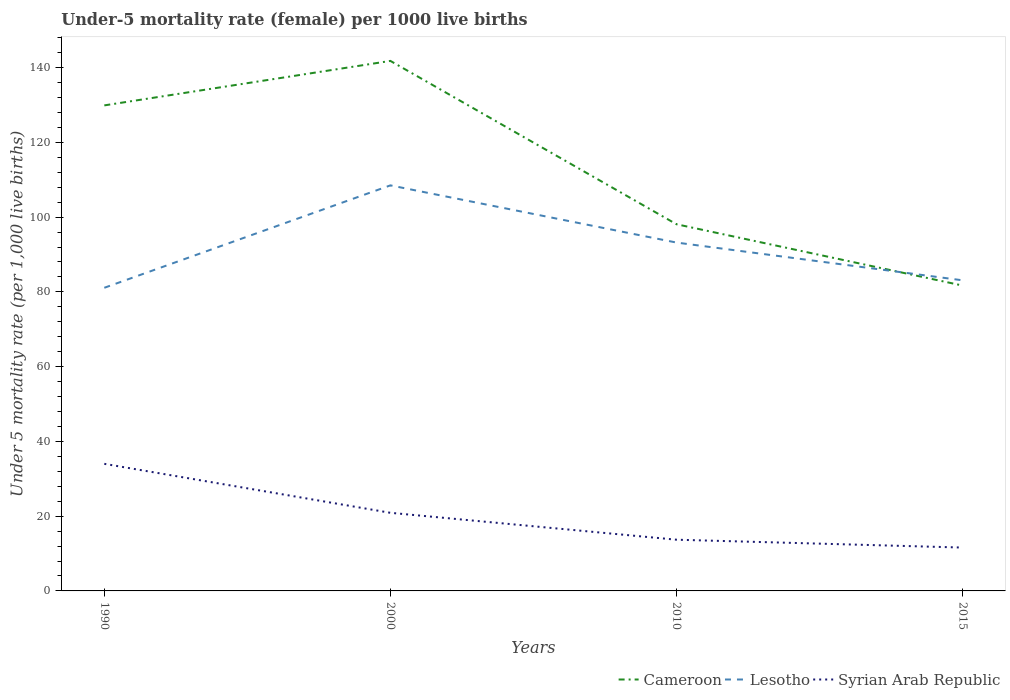Does the line corresponding to Syrian Arab Republic intersect with the line corresponding to Cameroon?
Ensure brevity in your answer.  No. Is the number of lines equal to the number of legend labels?
Ensure brevity in your answer.  Yes. Across all years, what is the maximum under-five mortality rate in Lesotho?
Give a very brief answer. 81.1. In which year was the under-five mortality rate in Cameroon maximum?
Keep it short and to the point. 2015. What is the total under-five mortality rate in Syrian Arab Republic in the graph?
Your answer should be compact. 13.1. What is the difference between the highest and the second highest under-five mortality rate in Syrian Arab Republic?
Ensure brevity in your answer.  22.4. How many years are there in the graph?
Your answer should be compact. 4. What is the difference between two consecutive major ticks on the Y-axis?
Provide a succinct answer. 20. Does the graph contain any zero values?
Provide a short and direct response. No. Does the graph contain grids?
Keep it short and to the point. No. Where does the legend appear in the graph?
Offer a very short reply. Bottom right. What is the title of the graph?
Offer a very short reply. Under-5 mortality rate (female) per 1000 live births. Does "Netherlands" appear as one of the legend labels in the graph?
Provide a succinct answer. No. What is the label or title of the Y-axis?
Make the answer very short. Under 5 mortality rate (per 1,0 live births). What is the Under 5 mortality rate (per 1,000 live births) of Cameroon in 1990?
Your answer should be compact. 129.9. What is the Under 5 mortality rate (per 1,000 live births) of Lesotho in 1990?
Provide a short and direct response. 81.1. What is the Under 5 mortality rate (per 1,000 live births) in Syrian Arab Republic in 1990?
Your answer should be compact. 34. What is the Under 5 mortality rate (per 1,000 live births) in Cameroon in 2000?
Provide a succinct answer. 141.8. What is the Under 5 mortality rate (per 1,000 live births) in Lesotho in 2000?
Offer a terse response. 108.5. What is the Under 5 mortality rate (per 1,000 live births) in Syrian Arab Republic in 2000?
Provide a short and direct response. 20.9. What is the Under 5 mortality rate (per 1,000 live births) in Cameroon in 2010?
Make the answer very short. 98.1. What is the Under 5 mortality rate (per 1,000 live births) of Lesotho in 2010?
Your answer should be compact. 93.2. What is the Under 5 mortality rate (per 1,000 live births) in Cameroon in 2015?
Your response must be concise. 81.7. What is the Under 5 mortality rate (per 1,000 live births) in Lesotho in 2015?
Your response must be concise. 83.1. Across all years, what is the maximum Under 5 mortality rate (per 1,000 live births) of Cameroon?
Ensure brevity in your answer.  141.8. Across all years, what is the maximum Under 5 mortality rate (per 1,000 live births) in Lesotho?
Your response must be concise. 108.5. Across all years, what is the minimum Under 5 mortality rate (per 1,000 live births) in Cameroon?
Provide a succinct answer. 81.7. Across all years, what is the minimum Under 5 mortality rate (per 1,000 live births) of Lesotho?
Make the answer very short. 81.1. Across all years, what is the minimum Under 5 mortality rate (per 1,000 live births) in Syrian Arab Republic?
Your response must be concise. 11.6. What is the total Under 5 mortality rate (per 1,000 live births) in Cameroon in the graph?
Ensure brevity in your answer.  451.5. What is the total Under 5 mortality rate (per 1,000 live births) of Lesotho in the graph?
Your response must be concise. 365.9. What is the total Under 5 mortality rate (per 1,000 live births) in Syrian Arab Republic in the graph?
Your answer should be very brief. 80.2. What is the difference between the Under 5 mortality rate (per 1,000 live births) in Cameroon in 1990 and that in 2000?
Provide a short and direct response. -11.9. What is the difference between the Under 5 mortality rate (per 1,000 live births) in Lesotho in 1990 and that in 2000?
Your answer should be very brief. -27.4. What is the difference between the Under 5 mortality rate (per 1,000 live births) of Syrian Arab Republic in 1990 and that in 2000?
Make the answer very short. 13.1. What is the difference between the Under 5 mortality rate (per 1,000 live births) of Cameroon in 1990 and that in 2010?
Your answer should be compact. 31.8. What is the difference between the Under 5 mortality rate (per 1,000 live births) in Lesotho in 1990 and that in 2010?
Give a very brief answer. -12.1. What is the difference between the Under 5 mortality rate (per 1,000 live births) of Syrian Arab Republic in 1990 and that in 2010?
Keep it short and to the point. 20.3. What is the difference between the Under 5 mortality rate (per 1,000 live births) in Cameroon in 1990 and that in 2015?
Provide a succinct answer. 48.2. What is the difference between the Under 5 mortality rate (per 1,000 live births) of Lesotho in 1990 and that in 2015?
Your response must be concise. -2. What is the difference between the Under 5 mortality rate (per 1,000 live births) of Syrian Arab Republic in 1990 and that in 2015?
Provide a succinct answer. 22.4. What is the difference between the Under 5 mortality rate (per 1,000 live births) of Cameroon in 2000 and that in 2010?
Provide a succinct answer. 43.7. What is the difference between the Under 5 mortality rate (per 1,000 live births) in Lesotho in 2000 and that in 2010?
Your answer should be very brief. 15.3. What is the difference between the Under 5 mortality rate (per 1,000 live births) of Syrian Arab Republic in 2000 and that in 2010?
Provide a succinct answer. 7.2. What is the difference between the Under 5 mortality rate (per 1,000 live births) in Cameroon in 2000 and that in 2015?
Ensure brevity in your answer.  60.1. What is the difference between the Under 5 mortality rate (per 1,000 live births) in Lesotho in 2000 and that in 2015?
Your answer should be very brief. 25.4. What is the difference between the Under 5 mortality rate (per 1,000 live births) in Syrian Arab Republic in 2000 and that in 2015?
Offer a very short reply. 9.3. What is the difference between the Under 5 mortality rate (per 1,000 live births) of Lesotho in 2010 and that in 2015?
Ensure brevity in your answer.  10.1. What is the difference between the Under 5 mortality rate (per 1,000 live births) of Cameroon in 1990 and the Under 5 mortality rate (per 1,000 live births) of Lesotho in 2000?
Ensure brevity in your answer.  21.4. What is the difference between the Under 5 mortality rate (per 1,000 live births) in Cameroon in 1990 and the Under 5 mortality rate (per 1,000 live births) in Syrian Arab Republic in 2000?
Offer a very short reply. 109. What is the difference between the Under 5 mortality rate (per 1,000 live births) of Lesotho in 1990 and the Under 5 mortality rate (per 1,000 live births) of Syrian Arab Republic in 2000?
Provide a succinct answer. 60.2. What is the difference between the Under 5 mortality rate (per 1,000 live births) in Cameroon in 1990 and the Under 5 mortality rate (per 1,000 live births) in Lesotho in 2010?
Give a very brief answer. 36.7. What is the difference between the Under 5 mortality rate (per 1,000 live births) of Cameroon in 1990 and the Under 5 mortality rate (per 1,000 live births) of Syrian Arab Republic in 2010?
Make the answer very short. 116.2. What is the difference between the Under 5 mortality rate (per 1,000 live births) of Lesotho in 1990 and the Under 5 mortality rate (per 1,000 live births) of Syrian Arab Republic in 2010?
Provide a succinct answer. 67.4. What is the difference between the Under 5 mortality rate (per 1,000 live births) in Cameroon in 1990 and the Under 5 mortality rate (per 1,000 live births) in Lesotho in 2015?
Your answer should be very brief. 46.8. What is the difference between the Under 5 mortality rate (per 1,000 live births) of Cameroon in 1990 and the Under 5 mortality rate (per 1,000 live births) of Syrian Arab Republic in 2015?
Provide a short and direct response. 118.3. What is the difference between the Under 5 mortality rate (per 1,000 live births) in Lesotho in 1990 and the Under 5 mortality rate (per 1,000 live births) in Syrian Arab Republic in 2015?
Make the answer very short. 69.5. What is the difference between the Under 5 mortality rate (per 1,000 live births) in Cameroon in 2000 and the Under 5 mortality rate (per 1,000 live births) in Lesotho in 2010?
Offer a terse response. 48.6. What is the difference between the Under 5 mortality rate (per 1,000 live births) of Cameroon in 2000 and the Under 5 mortality rate (per 1,000 live births) of Syrian Arab Republic in 2010?
Offer a terse response. 128.1. What is the difference between the Under 5 mortality rate (per 1,000 live births) of Lesotho in 2000 and the Under 5 mortality rate (per 1,000 live births) of Syrian Arab Republic in 2010?
Provide a succinct answer. 94.8. What is the difference between the Under 5 mortality rate (per 1,000 live births) in Cameroon in 2000 and the Under 5 mortality rate (per 1,000 live births) in Lesotho in 2015?
Your answer should be compact. 58.7. What is the difference between the Under 5 mortality rate (per 1,000 live births) of Cameroon in 2000 and the Under 5 mortality rate (per 1,000 live births) of Syrian Arab Republic in 2015?
Your answer should be compact. 130.2. What is the difference between the Under 5 mortality rate (per 1,000 live births) in Lesotho in 2000 and the Under 5 mortality rate (per 1,000 live births) in Syrian Arab Republic in 2015?
Provide a succinct answer. 96.9. What is the difference between the Under 5 mortality rate (per 1,000 live births) in Cameroon in 2010 and the Under 5 mortality rate (per 1,000 live births) in Lesotho in 2015?
Provide a short and direct response. 15. What is the difference between the Under 5 mortality rate (per 1,000 live births) in Cameroon in 2010 and the Under 5 mortality rate (per 1,000 live births) in Syrian Arab Republic in 2015?
Offer a terse response. 86.5. What is the difference between the Under 5 mortality rate (per 1,000 live births) in Lesotho in 2010 and the Under 5 mortality rate (per 1,000 live births) in Syrian Arab Republic in 2015?
Provide a succinct answer. 81.6. What is the average Under 5 mortality rate (per 1,000 live births) of Cameroon per year?
Make the answer very short. 112.88. What is the average Under 5 mortality rate (per 1,000 live births) of Lesotho per year?
Offer a terse response. 91.47. What is the average Under 5 mortality rate (per 1,000 live births) of Syrian Arab Republic per year?
Make the answer very short. 20.05. In the year 1990, what is the difference between the Under 5 mortality rate (per 1,000 live births) of Cameroon and Under 5 mortality rate (per 1,000 live births) of Lesotho?
Provide a succinct answer. 48.8. In the year 1990, what is the difference between the Under 5 mortality rate (per 1,000 live births) of Cameroon and Under 5 mortality rate (per 1,000 live births) of Syrian Arab Republic?
Your answer should be very brief. 95.9. In the year 1990, what is the difference between the Under 5 mortality rate (per 1,000 live births) of Lesotho and Under 5 mortality rate (per 1,000 live births) of Syrian Arab Republic?
Your answer should be very brief. 47.1. In the year 2000, what is the difference between the Under 5 mortality rate (per 1,000 live births) in Cameroon and Under 5 mortality rate (per 1,000 live births) in Lesotho?
Make the answer very short. 33.3. In the year 2000, what is the difference between the Under 5 mortality rate (per 1,000 live births) of Cameroon and Under 5 mortality rate (per 1,000 live births) of Syrian Arab Republic?
Ensure brevity in your answer.  120.9. In the year 2000, what is the difference between the Under 5 mortality rate (per 1,000 live births) of Lesotho and Under 5 mortality rate (per 1,000 live births) of Syrian Arab Republic?
Offer a terse response. 87.6. In the year 2010, what is the difference between the Under 5 mortality rate (per 1,000 live births) in Cameroon and Under 5 mortality rate (per 1,000 live births) in Lesotho?
Give a very brief answer. 4.9. In the year 2010, what is the difference between the Under 5 mortality rate (per 1,000 live births) in Cameroon and Under 5 mortality rate (per 1,000 live births) in Syrian Arab Republic?
Keep it short and to the point. 84.4. In the year 2010, what is the difference between the Under 5 mortality rate (per 1,000 live births) in Lesotho and Under 5 mortality rate (per 1,000 live births) in Syrian Arab Republic?
Provide a succinct answer. 79.5. In the year 2015, what is the difference between the Under 5 mortality rate (per 1,000 live births) of Cameroon and Under 5 mortality rate (per 1,000 live births) of Syrian Arab Republic?
Offer a terse response. 70.1. In the year 2015, what is the difference between the Under 5 mortality rate (per 1,000 live births) in Lesotho and Under 5 mortality rate (per 1,000 live births) in Syrian Arab Republic?
Your answer should be compact. 71.5. What is the ratio of the Under 5 mortality rate (per 1,000 live births) of Cameroon in 1990 to that in 2000?
Offer a terse response. 0.92. What is the ratio of the Under 5 mortality rate (per 1,000 live births) in Lesotho in 1990 to that in 2000?
Keep it short and to the point. 0.75. What is the ratio of the Under 5 mortality rate (per 1,000 live births) of Syrian Arab Republic in 1990 to that in 2000?
Your answer should be very brief. 1.63. What is the ratio of the Under 5 mortality rate (per 1,000 live births) in Cameroon in 1990 to that in 2010?
Your answer should be very brief. 1.32. What is the ratio of the Under 5 mortality rate (per 1,000 live births) of Lesotho in 1990 to that in 2010?
Provide a succinct answer. 0.87. What is the ratio of the Under 5 mortality rate (per 1,000 live births) of Syrian Arab Republic in 1990 to that in 2010?
Your answer should be compact. 2.48. What is the ratio of the Under 5 mortality rate (per 1,000 live births) in Cameroon in 1990 to that in 2015?
Offer a very short reply. 1.59. What is the ratio of the Under 5 mortality rate (per 1,000 live births) of Lesotho in 1990 to that in 2015?
Your answer should be compact. 0.98. What is the ratio of the Under 5 mortality rate (per 1,000 live births) of Syrian Arab Republic in 1990 to that in 2015?
Give a very brief answer. 2.93. What is the ratio of the Under 5 mortality rate (per 1,000 live births) of Cameroon in 2000 to that in 2010?
Provide a succinct answer. 1.45. What is the ratio of the Under 5 mortality rate (per 1,000 live births) of Lesotho in 2000 to that in 2010?
Your response must be concise. 1.16. What is the ratio of the Under 5 mortality rate (per 1,000 live births) in Syrian Arab Republic in 2000 to that in 2010?
Your response must be concise. 1.53. What is the ratio of the Under 5 mortality rate (per 1,000 live births) of Cameroon in 2000 to that in 2015?
Keep it short and to the point. 1.74. What is the ratio of the Under 5 mortality rate (per 1,000 live births) of Lesotho in 2000 to that in 2015?
Provide a succinct answer. 1.31. What is the ratio of the Under 5 mortality rate (per 1,000 live births) in Syrian Arab Republic in 2000 to that in 2015?
Make the answer very short. 1.8. What is the ratio of the Under 5 mortality rate (per 1,000 live births) in Cameroon in 2010 to that in 2015?
Provide a succinct answer. 1.2. What is the ratio of the Under 5 mortality rate (per 1,000 live births) in Lesotho in 2010 to that in 2015?
Offer a very short reply. 1.12. What is the ratio of the Under 5 mortality rate (per 1,000 live births) of Syrian Arab Republic in 2010 to that in 2015?
Your response must be concise. 1.18. What is the difference between the highest and the second highest Under 5 mortality rate (per 1,000 live births) of Cameroon?
Your answer should be compact. 11.9. What is the difference between the highest and the second highest Under 5 mortality rate (per 1,000 live births) of Syrian Arab Republic?
Your answer should be compact. 13.1. What is the difference between the highest and the lowest Under 5 mortality rate (per 1,000 live births) of Cameroon?
Ensure brevity in your answer.  60.1. What is the difference between the highest and the lowest Under 5 mortality rate (per 1,000 live births) of Lesotho?
Offer a very short reply. 27.4. What is the difference between the highest and the lowest Under 5 mortality rate (per 1,000 live births) in Syrian Arab Republic?
Keep it short and to the point. 22.4. 